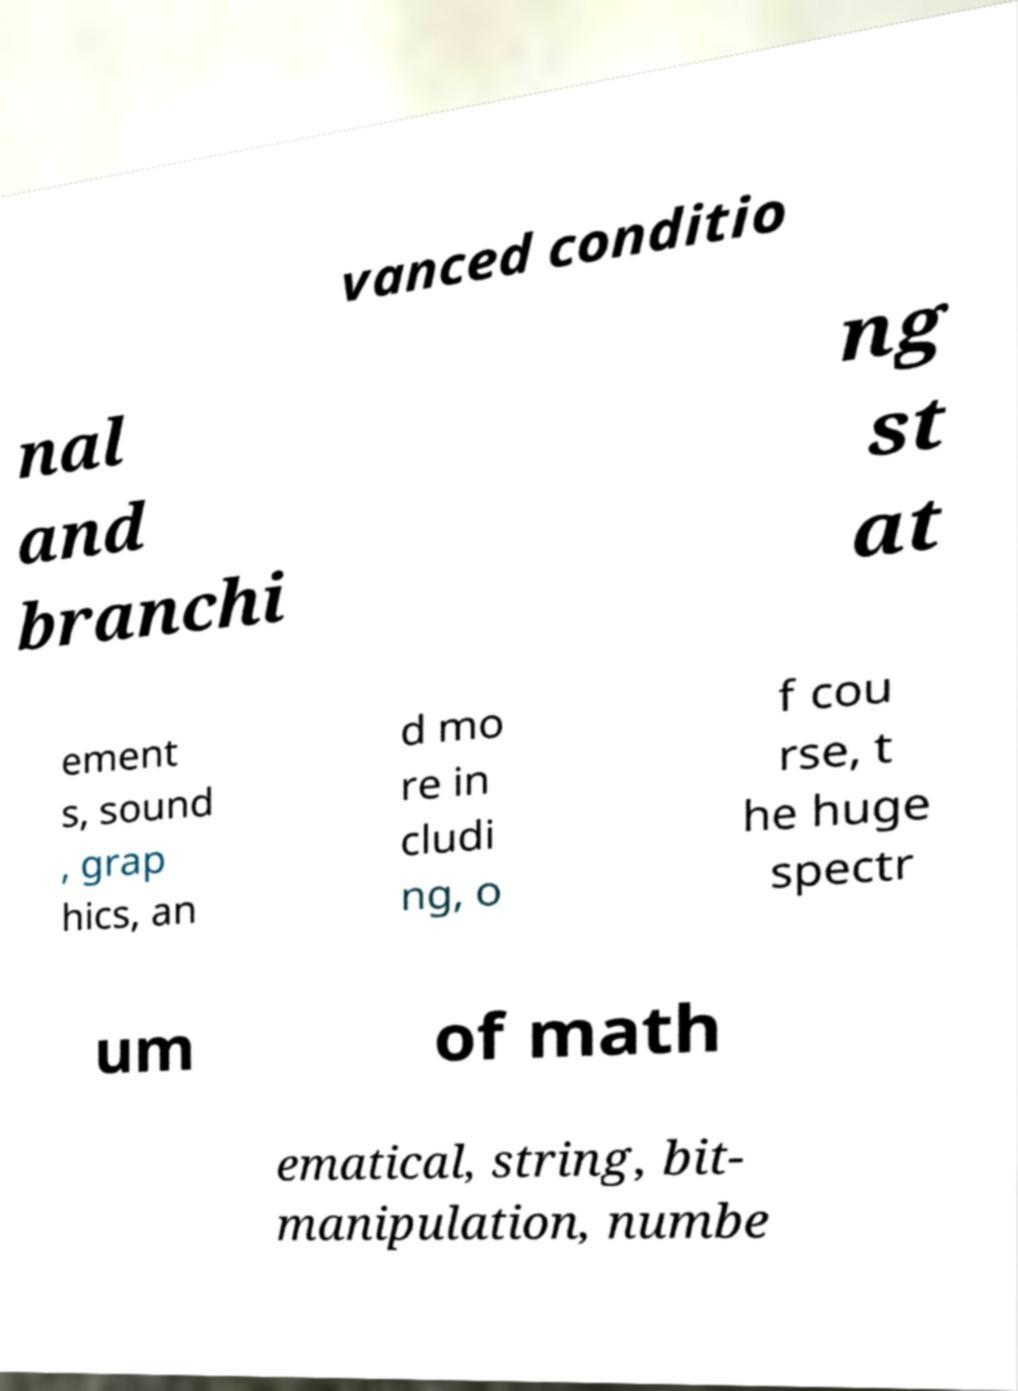There's text embedded in this image that I need extracted. Can you transcribe it verbatim? vanced conditio nal and branchi ng st at ement s, sound , grap hics, an d mo re in cludi ng, o f cou rse, t he huge spectr um of math ematical, string, bit- manipulation, numbe 